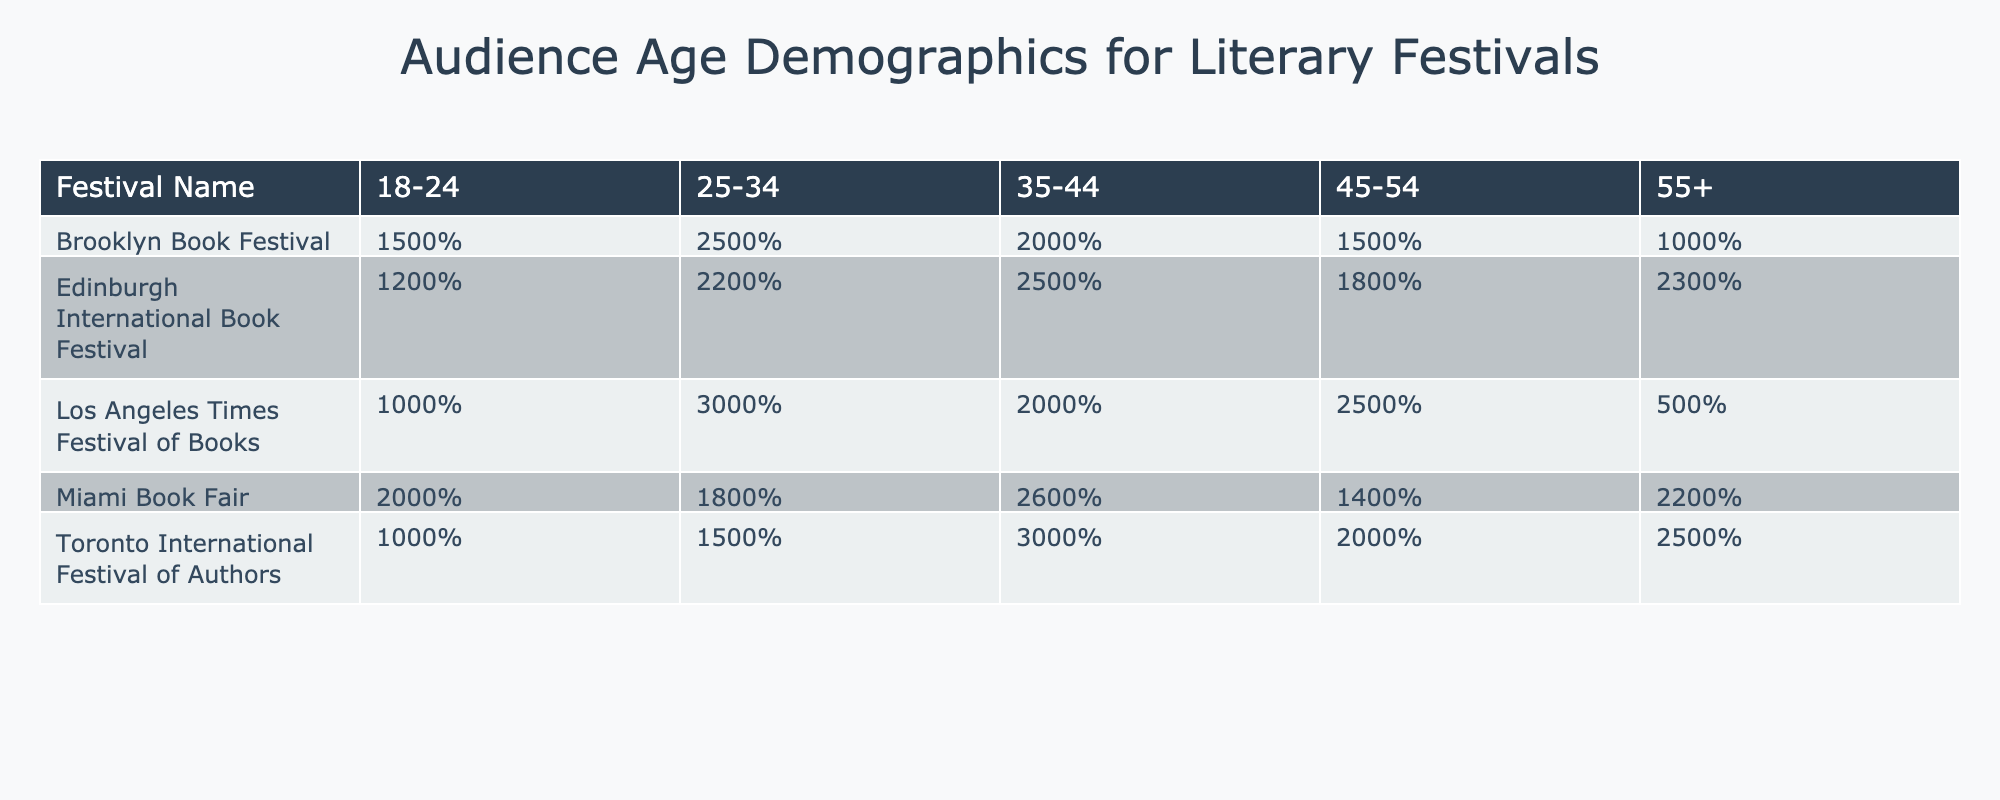What percentage of the audience at the Brooklyn Book Festival is aged 35-44? Referring to the table, the percentage for the age group 35-44 at the Brooklyn Book Festival is directly listed as 20%.
Answer: 20% Which festival has the highest percentage of attendees aged 25-34? By comparing the percentages for the age group 25-34 across all festivals, the Los Angeles Times Festival of Books has the highest percentage at 30%.
Answer: Los Angeles Times Festival of Books What is the total percentage of attendees aged 55+ across all festivals? By adding the percentages of the 55+ age group for each festival: 10 + 5 + 23 + 22 + 25 = 85%.
Answer: 85% Is the percentage of attendees aged 18-24 at the Miami Book Fair greater than that at the Toronto International Festival of Authors? The Miami Book Fair has 20% for the 18-24 age group, while the Toronto International Festival of Authors has 10%, so yes, Miami's percentage is greater.
Answer: Yes What is the average percentage of attendees aged 45-54 across all festivals? To find the average, first add the percentages for the age group 45-54: 15 + 25 + 18 + 14 + 20 = 92. Then divide by the number of festivals (5): 92/5 = 18.4%.
Answer: 18.4% Which age group at the Edinburgh International Book Festival has the lowest percentage? Looking at the percentages for the Edinburgh International Book Festival, the age group with the lowest percentage is 18-24, which is 12%.
Answer: 12% If we consider the 35-44 age group, which festival has the lowest percentage? The lowest percentage for the 35-44 age group is at the Los Angeles Times Festival of Books, with a percentage of 20%.
Answer: Los Angeles Times Festival of Books What percentage of the audience at the Miami Book Fair is aged 25-34 compared to the percentage of the same age group at the Brooklyn Book Festival? The Miami Book Fair has 18% for the 25-34 age group, and the Brooklyn Book Festival has 25%, making Miami's percentage lower.
Answer: Lower How does the percentage of attendees aged 55+ at the Edinburgh International Book Festival compare to the percentage at the Brooklyn Book Festival? The percentage of attendees aged 55+ at the Edinburgh International Book Festival is 23%, which is higher than the 10% at the Brooklyn Book Festival.
Answer: Higher What is the difference in audience percentage for the age group 18-24 between the Miami Book Fair and the Los Angeles Times Festival of Books? Miami Book Fair has 20% and the Los Angeles Times Festival of Books has 10%. The difference is 20% - 10% = 10%.
Answer: 10% 